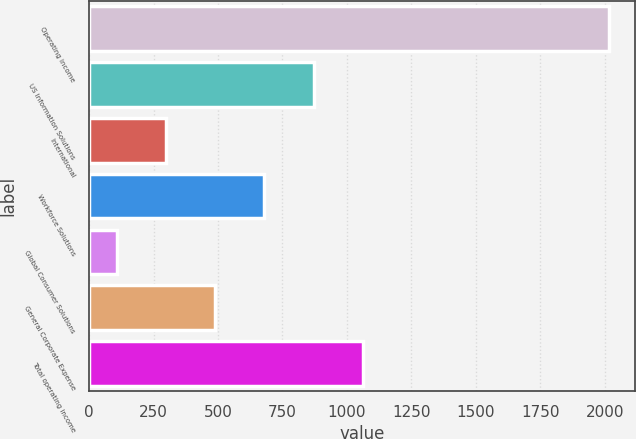Convert chart to OTSL. <chart><loc_0><loc_0><loc_500><loc_500><bar_chart><fcel>Operating income<fcel>US Information Solutions<fcel>International<fcel>Workforce Solutions<fcel>Global Consumer Solutions<fcel>General Corporate Expense<fcel>Total operating income<nl><fcel>2017<fcel>870.52<fcel>297.28<fcel>679.44<fcel>106.2<fcel>488.36<fcel>1061.6<nl></chart> 